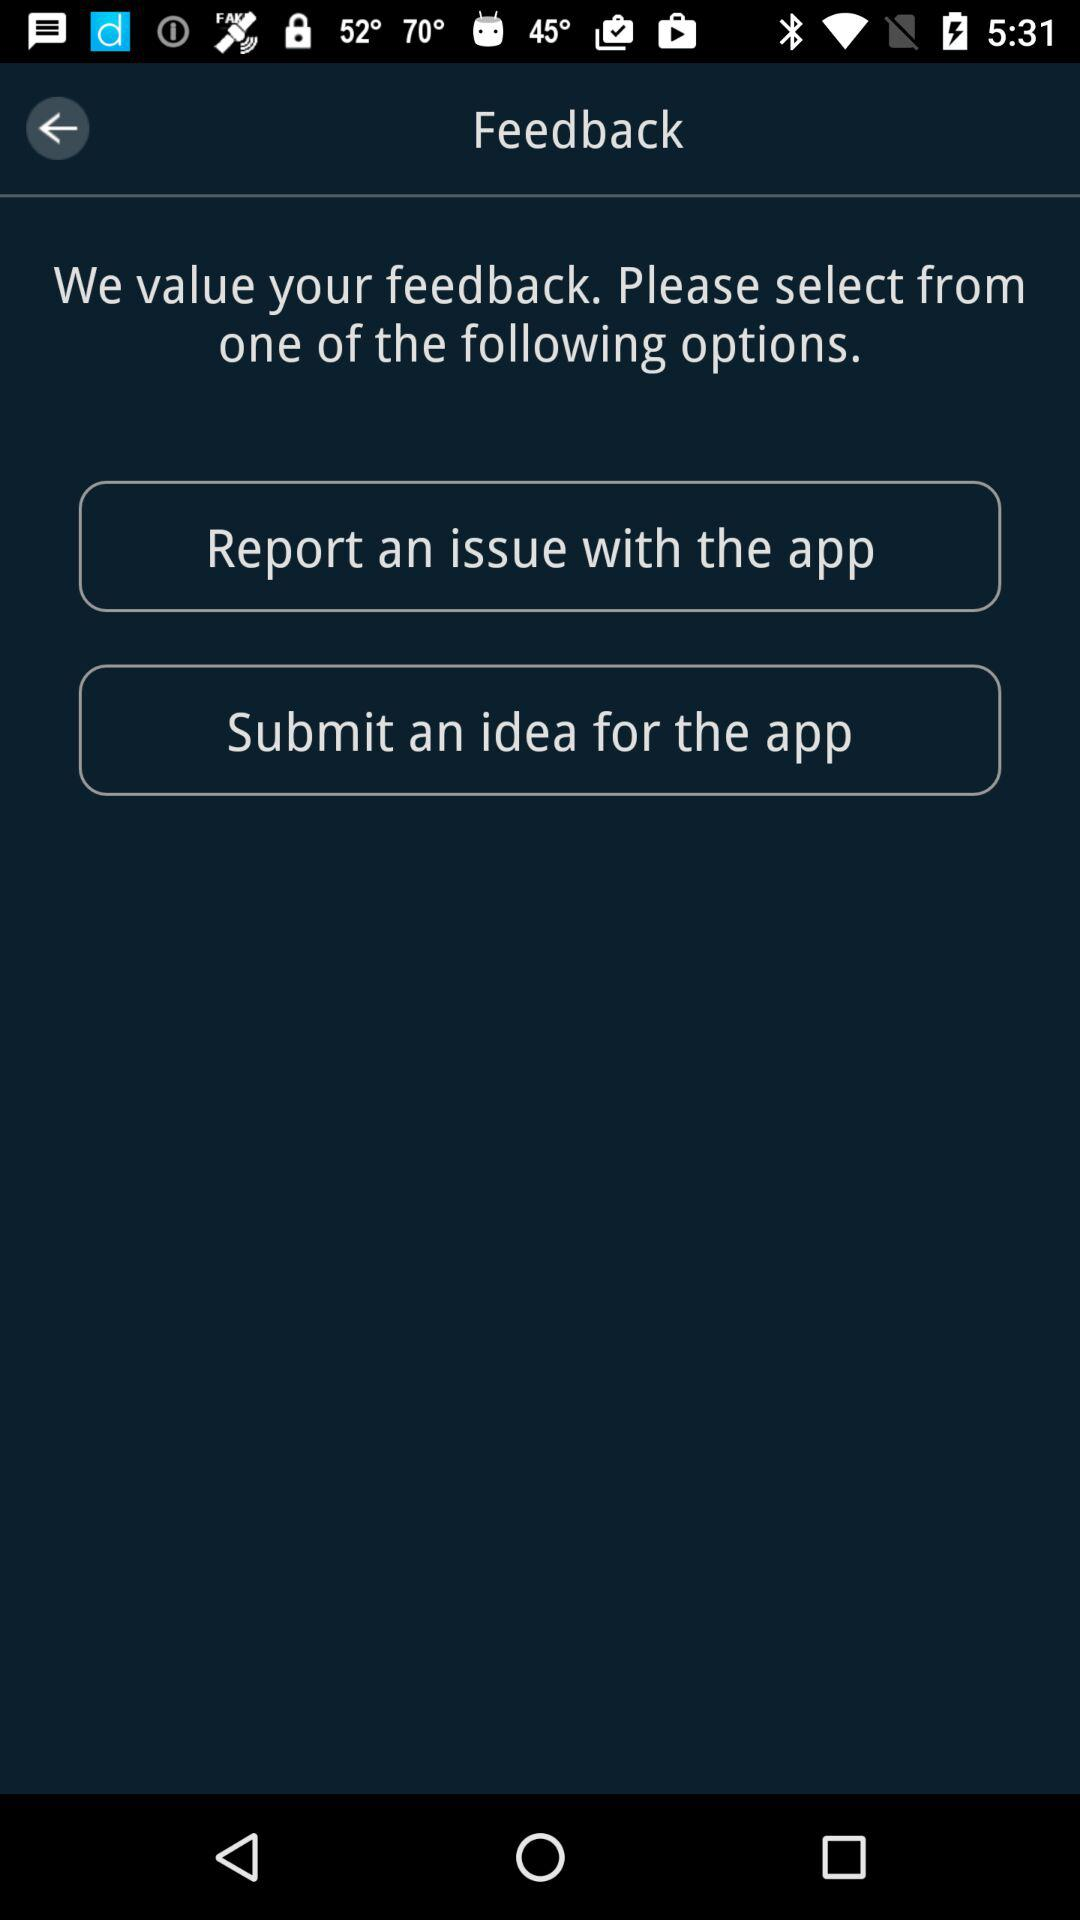Who do we contact to give feedback?
When the provided information is insufficient, respond with <no answer>. <no answer> 